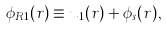Convert formula to latex. <formula><loc_0><loc_0><loc_500><loc_500>\phi _ { R 1 } ( r ) \equiv u _ { 1 } ( r ) + \phi _ { s } ( r ) ,</formula> 